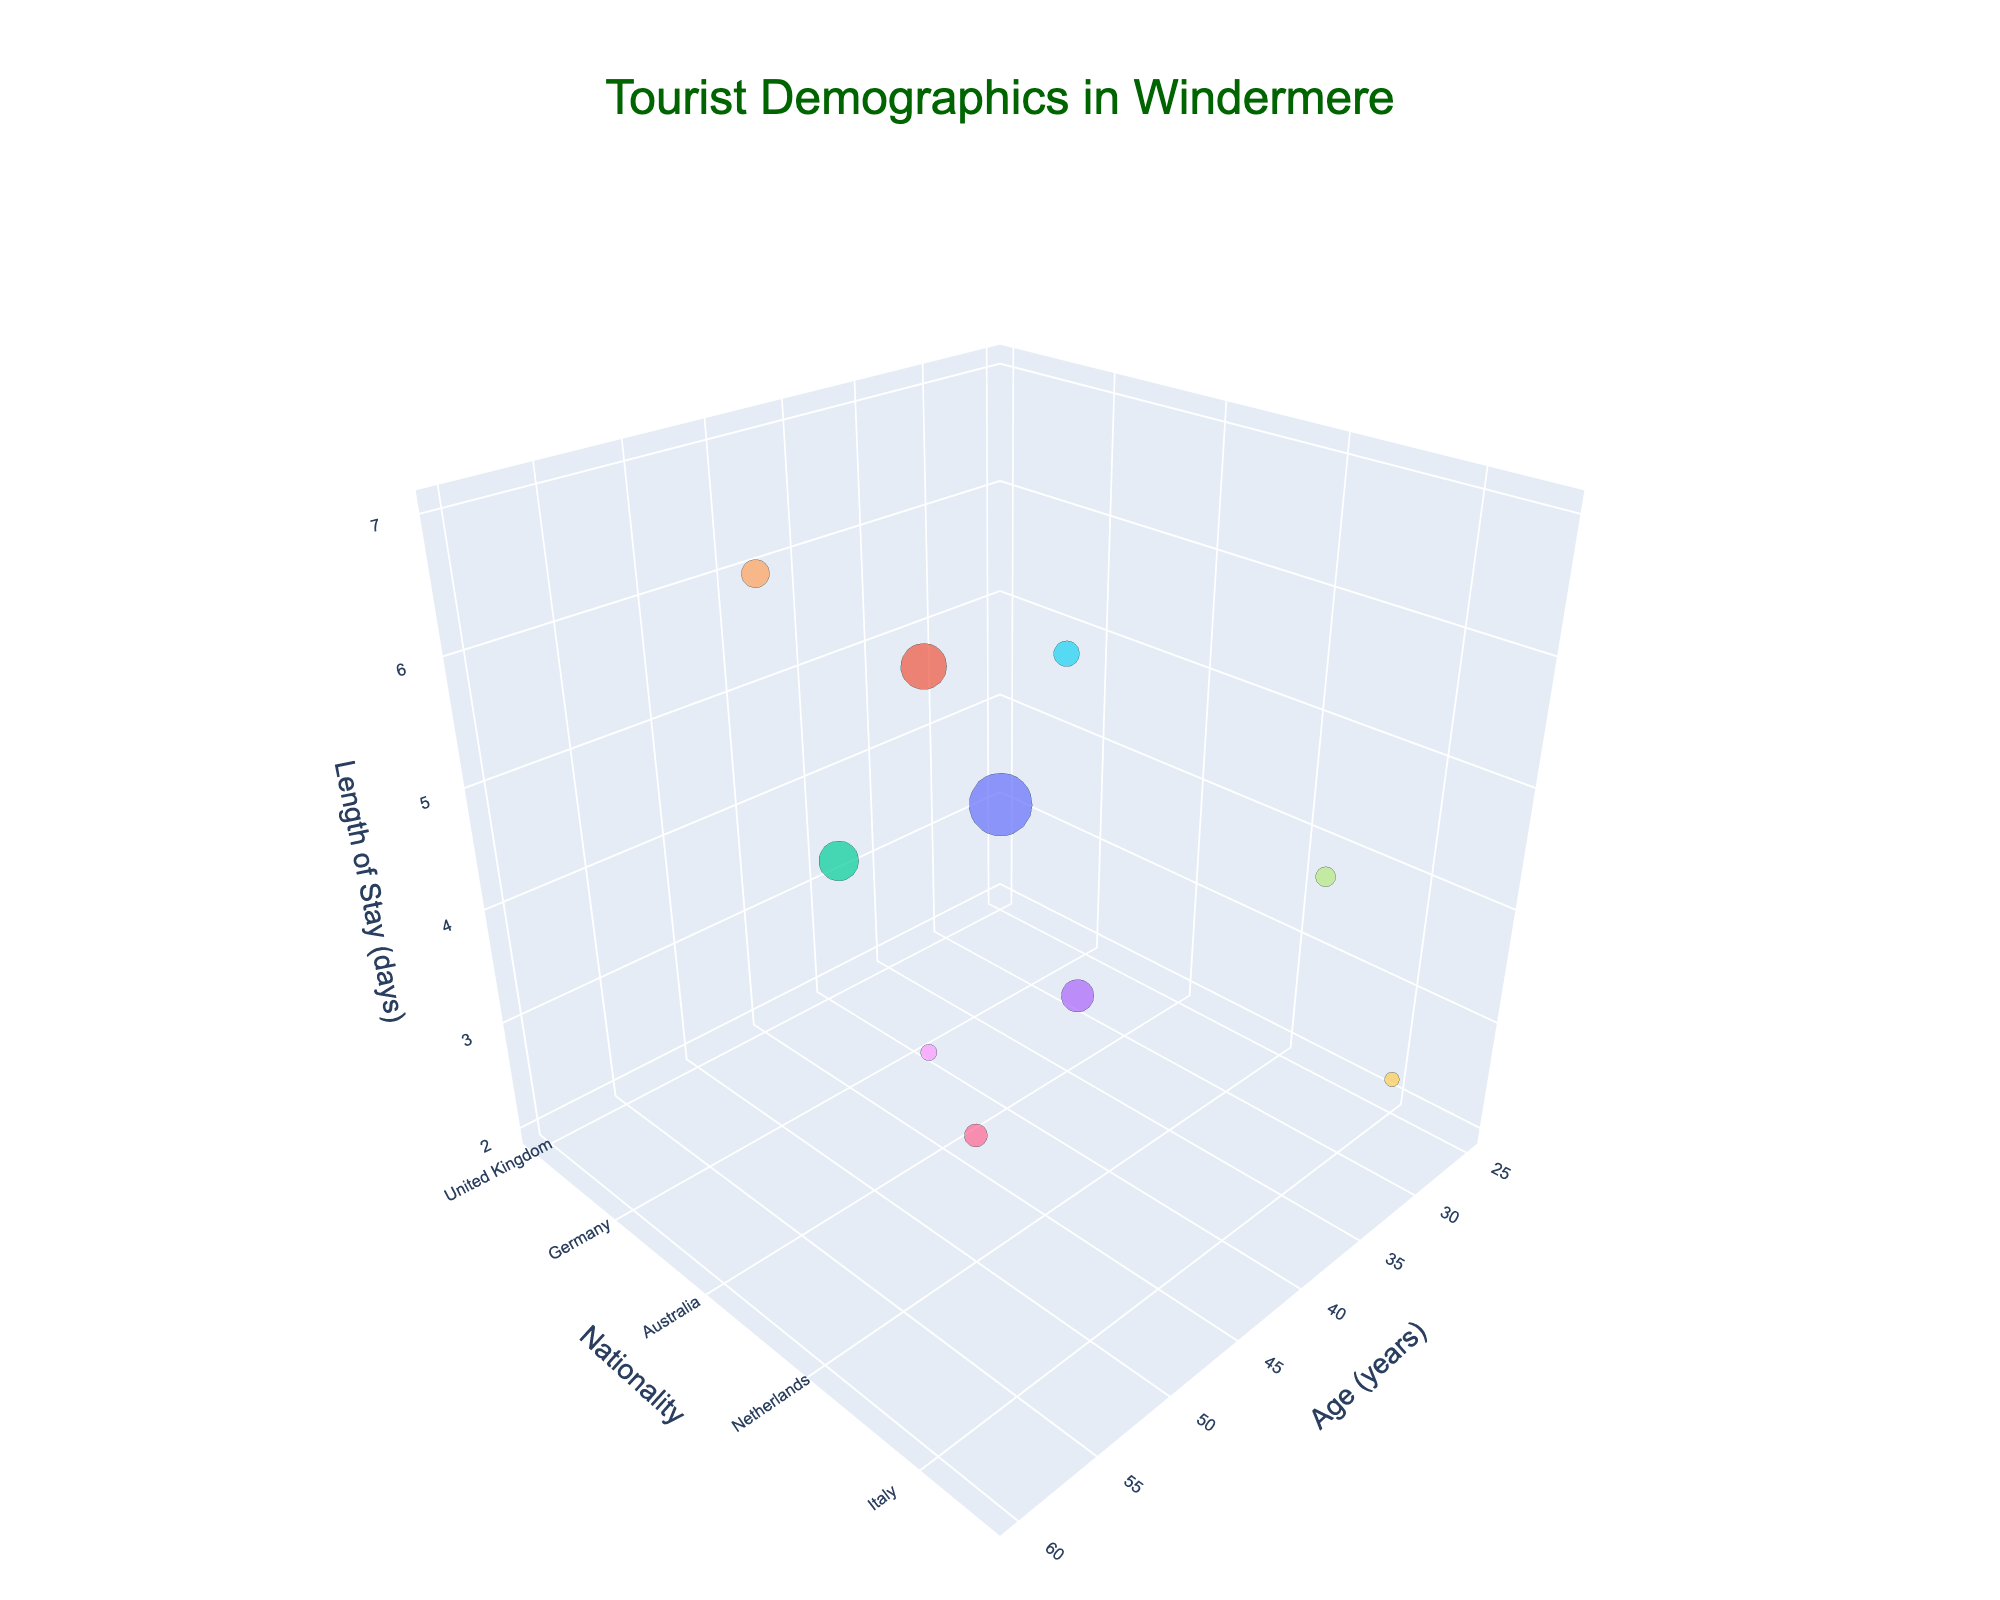How many tourists are represented from the United States? Identify the bubble for the United States and refer to its size, which represents 800 visitors.
Answer: 800 Which nationality shows the longest average length of stay? Look for the bubble positioned highest on the z-axis (Length of Stay). The highest point corresponds to Australia with a length of stay of 7 days.
Answer: Australia Compare the number of visitors between Japan and Germany. Which country has fewer visitors? Check the size of the bubbles for Japan and Germany. Japan has 150 visitors, and Germany has 600 visitors. Therefore, Japan has fewer visitors.
Answer: Japan What age group has the youngest average age? Find the bubble that is positioned furthest left on the x-axis, which indicates age. The furthest left represents a tourist aged 25 from the United Kingdom. Therefore, tourists aged 25 are the youngest.
Answer: 25 What is the average length of stay for tourists aged 45 and 50? Identify the bubbles at age points 45 and 50. The lengths of stay for these groups are 4 days and 3 days, respectively. The average is (4 + 3) / 2 = 3.5 days.
Answer: 3.5 How many nationalities are represented in the figure? Count the different colored bubbles in the chart, which correspond to different nationalities. There are 10 different nationalities.
Answer: 10 Is the number of visitors from France greater than the number of visitors from Canada? Compare the sizes of the bubbles for France and Canada. France has 400 visitors, and Canada has 250 visitors. Therefore, France has more visitors.
Answer: Yes What is the range of ages of tourists visiting Windermere? Identify the lowest and highest ages in the chart. The age ranges from 25 to 60 years. Therefore, the range is 60 - 25 = 35 years.
Answer: 35 Which nationality has the shortest length of stay and what is it? Find the bubble positioned lowest on the z-axis. The French bubble is at 2 days, which is the shortest length of stay.
Answer: France, 2 days 